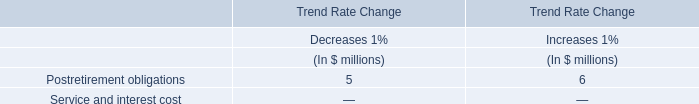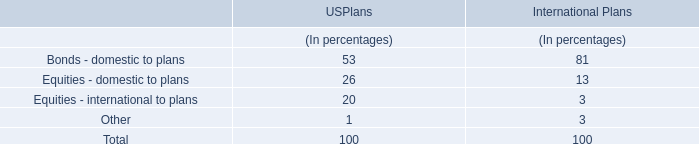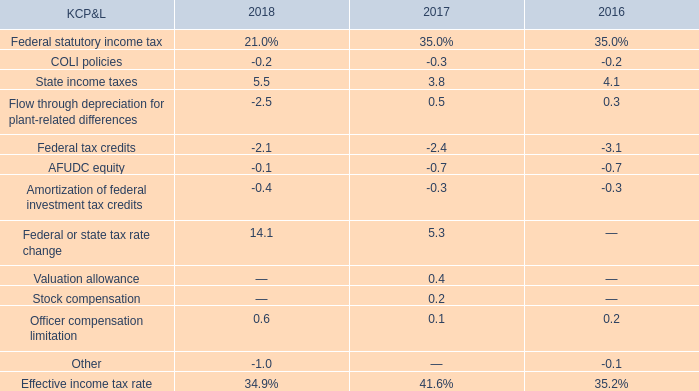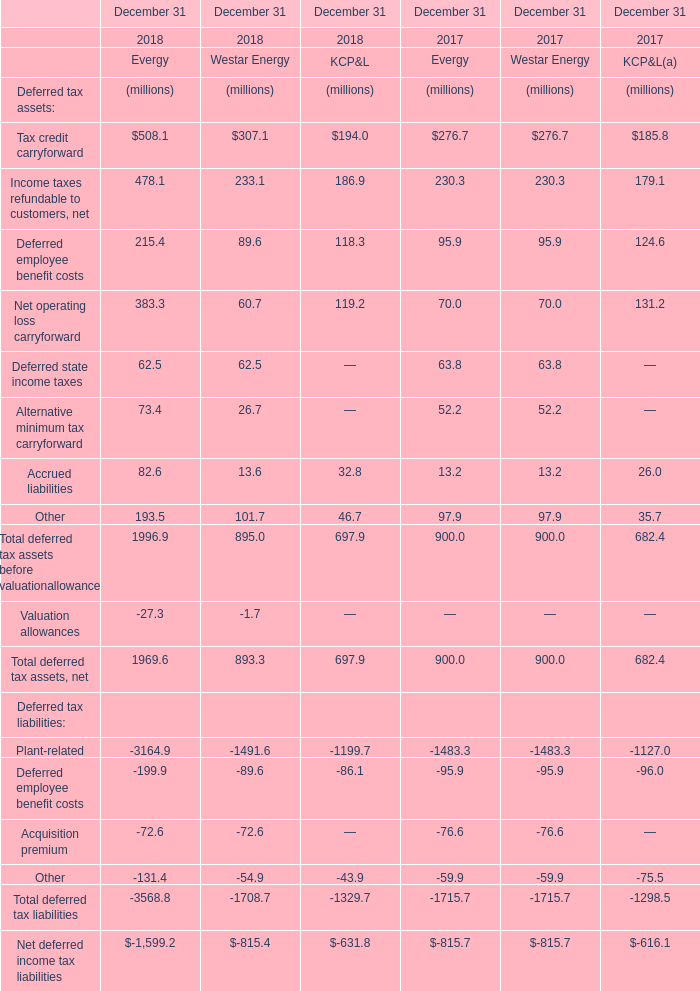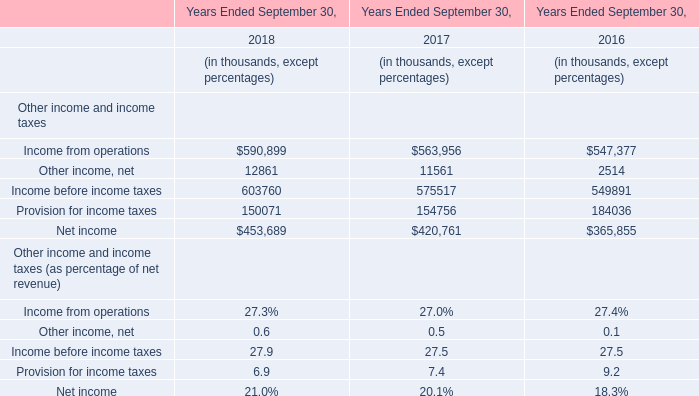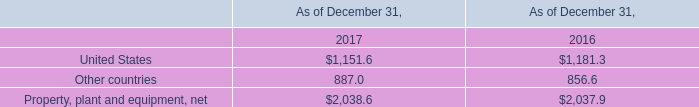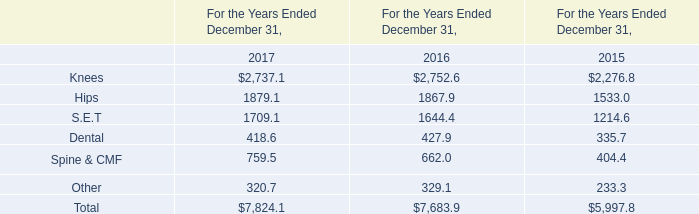Which section is Deferred employee benefit costs the most? 
Answer: Evergy in 2018. 